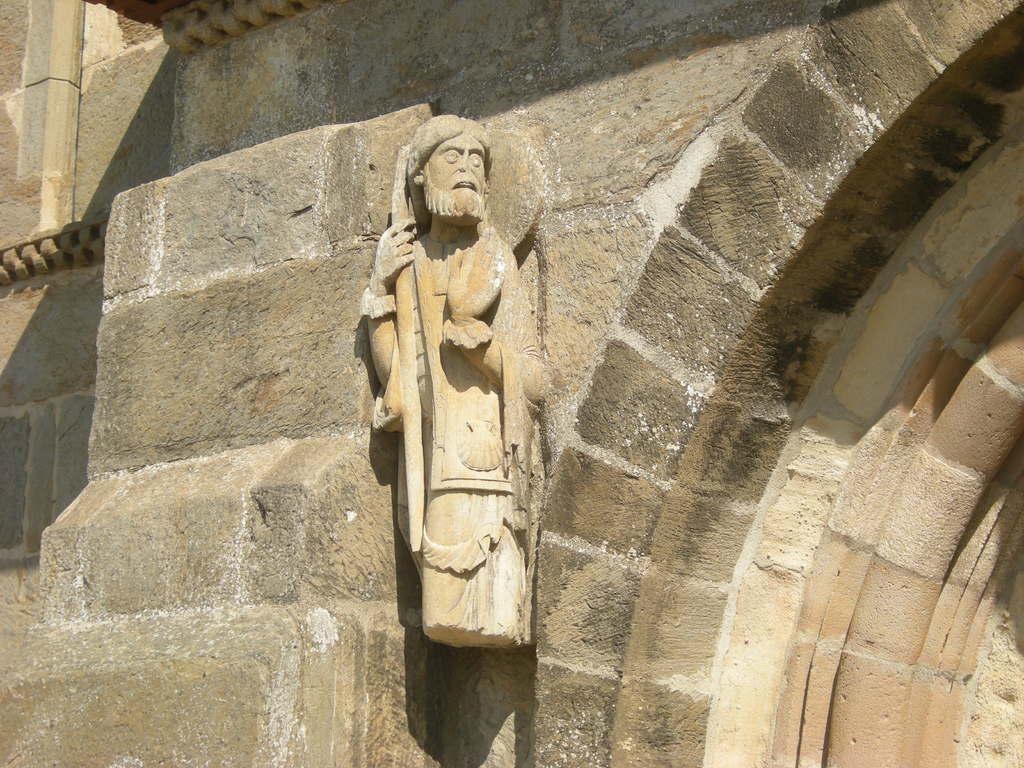In one or two sentences, can you explain what this image depicts? In the foreground of this image, there is a stone sculpture to the wall and on the right, it seems like an arch. 